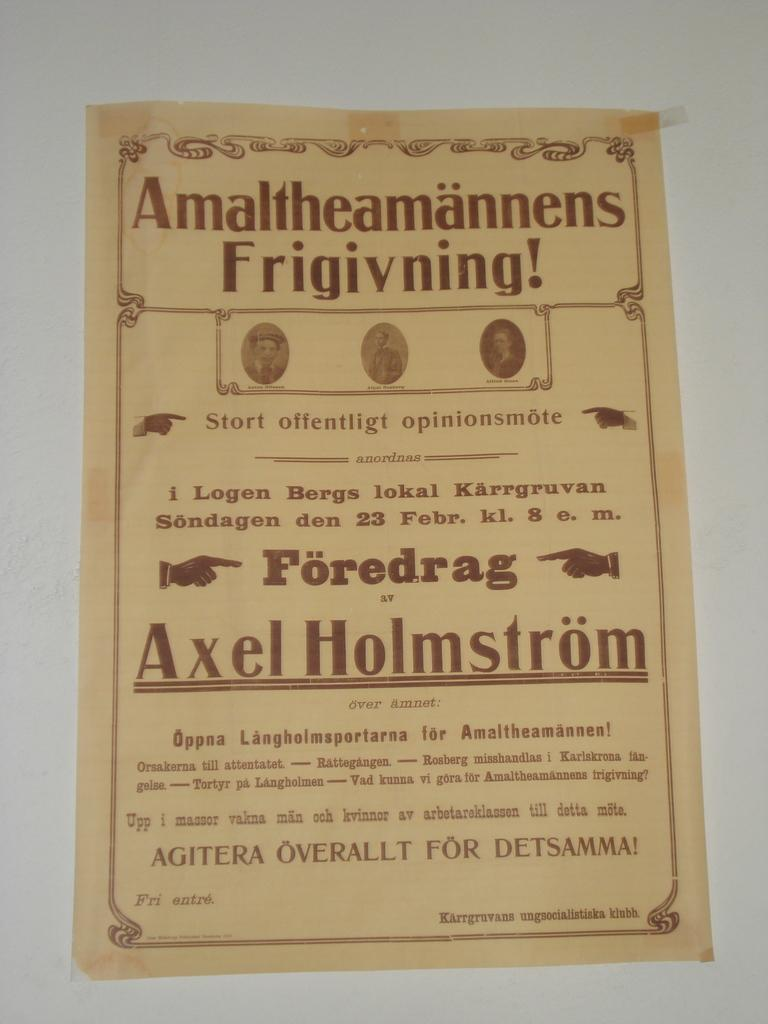<image>
Share a concise interpretation of the image provided. Some type of advertisement in another language that is featuring Axel Holmstrom. 